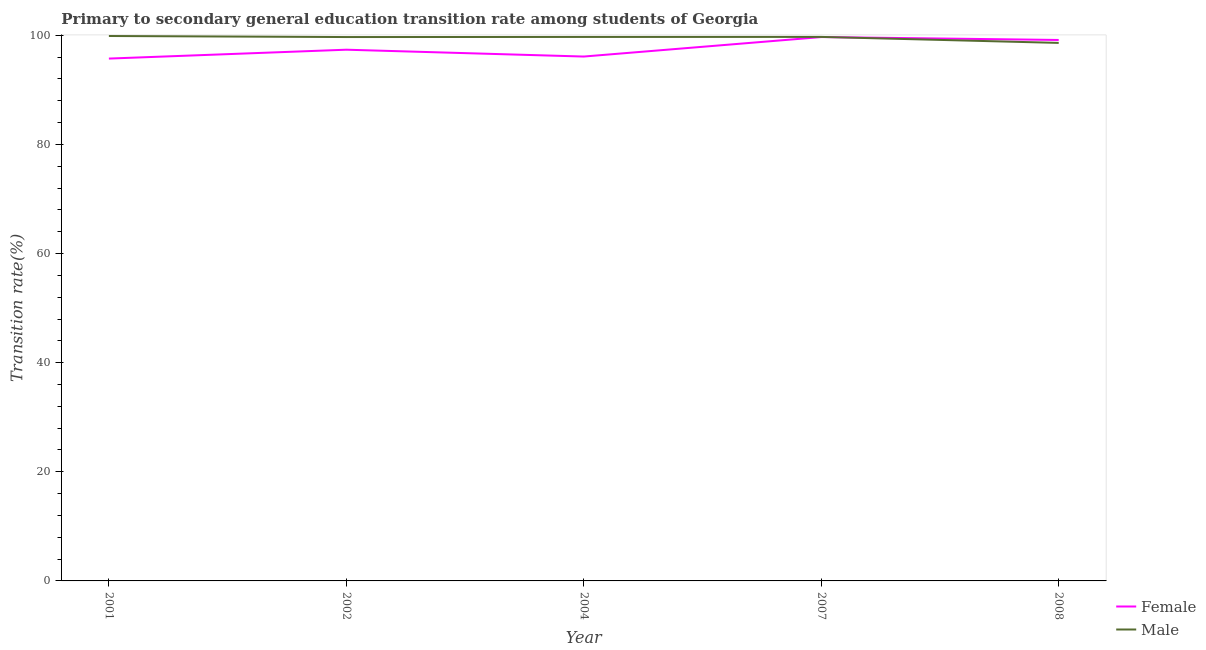What is the transition rate among male students in 2007?
Offer a terse response. 99.71. Across all years, what is the maximum transition rate among male students?
Offer a terse response. 99.88. Across all years, what is the minimum transition rate among male students?
Your response must be concise. 98.61. In which year was the transition rate among female students minimum?
Provide a succinct answer. 2001. What is the total transition rate among female students in the graph?
Your answer should be compact. 488.04. What is the difference between the transition rate among male students in 2002 and that in 2007?
Offer a terse response. -0.02. What is the difference between the transition rate among female students in 2002 and the transition rate among male students in 2008?
Provide a succinct answer. -1.24. What is the average transition rate among female students per year?
Your response must be concise. 97.61. In the year 2004, what is the difference between the transition rate among female students and transition rate among male students?
Provide a succinct answer. -3.59. What is the ratio of the transition rate among female students in 2002 to that in 2004?
Ensure brevity in your answer.  1.01. What is the difference between the highest and the second highest transition rate among male students?
Keep it short and to the point. 0.17. What is the difference between the highest and the lowest transition rate among male students?
Offer a very short reply. 1.27. Does the transition rate among female students monotonically increase over the years?
Your answer should be very brief. No. Is the transition rate among female students strictly less than the transition rate among male students over the years?
Keep it short and to the point. No. What is the difference between two consecutive major ticks on the Y-axis?
Your answer should be compact. 20. Are the values on the major ticks of Y-axis written in scientific E-notation?
Provide a succinct answer. No. Where does the legend appear in the graph?
Ensure brevity in your answer.  Bottom right. How many legend labels are there?
Provide a short and direct response. 2. How are the legend labels stacked?
Keep it short and to the point. Vertical. What is the title of the graph?
Your answer should be very brief. Primary to secondary general education transition rate among students of Georgia. Does "Manufacturing industries and construction" appear as one of the legend labels in the graph?
Ensure brevity in your answer.  No. What is the label or title of the X-axis?
Provide a succinct answer. Year. What is the label or title of the Y-axis?
Ensure brevity in your answer.  Transition rate(%). What is the Transition rate(%) of Female in 2001?
Keep it short and to the point. 95.74. What is the Transition rate(%) in Male in 2001?
Provide a succinct answer. 99.88. What is the Transition rate(%) of Female in 2002?
Give a very brief answer. 97.36. What is the Transition rate(%) of Male in 2002?
Offer a very short reply. 99.68. What is the Transition rate(%) of Female in 2004?
Offer a very short reply. 96.11. What is the Transition rate(%) in Male in 2004?
Offer a terse response. 99.7. What is the Transition rate(%) in Female in 2007?
Make the answer very short. 99.68. What is the Transition rate(%) of Male in 2007?
Provide a short and direct response. 99.71. What is the Transition rate(%) of Female in 2008?
Offer a very short reply. 99.15. What is the Transition rate(%) of Male in 2008?
Provide a succinct answer. 98.61. Across all years, what is the maximum Transition rate(%) of Female?
Keep it short and to the point. 99.68. Across all years, what is the maximum Transition rate(%) of Male?
Your response must be concise. 99.88. Across all years, what is the minimum Transition rate(%) in Female?
Offer a terse response. 95.74. Across all years, what is the minimum Transition rate(%) of Male?
Give a very brief answer. 98.61. What is the total Transition rate(%) of Female in the graph?
Your response must be concise. 488.04. What is the total Transition rate(%) in Male in the graph?
Give a very brief answer. 497.58. What is the difference between the Transition rate(%) in Female in 2001 and that in 2002?
Provide a short and direct response. -1.63. What is the difference between the Transition rate(%) of Male in 2001 and that in 2002?
Your answer should be very brief. 0.19. What is the difference between the Transition rate(%) of Female in 2001 and that in 2004?
Your answer should be very brief. -0.37. What is the difference between the Transition rate(%) of Male in 2001 and that in 2004?
Give a very brief answer. 0.17. What is the difference between the Transition rate(%) in Female in 2001 and that in 2007?
Provide a short and direct response. -3.95. What is the difference between the Transition rate(%) in Male in 2001 and that in 2007?
Make the answer very short. 0.17. What is the difference between the Transition rate(%) of Female in 2001 and that in 2008?
Give a very brief answer. -3.41. What is the difference between the Transition rate(%) in Male in 2001 and that in 2008?
Offer a terse response. 1.27. What is the difference between the Transition rate(%) in Female in 2002 and that in 2004?
Your answer should be very brief. 1.25. What is the difference between the Transition rate(%) of Male in 2002 and that in 2004?
Your answer should be compact. -0.02. What is the difference between the Transition rate(%) in Female in 2002 and that in 2007?
Your response must be concise. -2.32. What is the difference between the Transition rate(%) of Male in 2002 and that in 2007?
Your answer should be very brief. -0.02. What is the difference between the Transition rate(%) of Female in 2002 and that in 2008?
Offer a very short reply. -1.78. What is the difference between the Transition rate(%) of Male in 2002 and that in 2008?
Offer a terse response. 1.08. What is the difference between the Transition rate(%) of Female in 2004 and that in 2007?
Offer a terse response. -3.57. What is the difference between the Transition rate(%) of Male in 2004 and that in 2007?
Ensure brevity in your answer.  -0. What is the difference between the Transition rate(%) of Female in 2004 and that in 2008?
Your response must be concise. -3.04. What is the difference between the Transition rate(%) in Male in 2004 and that in 2008?
Your answer should be very brief. 1.1. What is the difference between the Transition rate(%) in Female in 2007 and that in 2008?
Your answer should be compact. 0.54. What is the difference between the Transition rate(%) in Male in 2007 and that in 2008?
Provide a succinct answer. 1.1. What is the difference between the Transition rate(%) in Female in 2001 and the Transition rate(%) in Male in 2002?
Ensure brevity in your answer.  -3.95. What is the difference between the Transition rate(%) in Female in 2001 and the Transition rate(%) in Male in 2004?
Ensure brevity in your answer.  -3.97. What is the difference between the Transition rate(%) of Female in 2001 and the Transition rate(%) of Male in 2007?
Offer a very short reply. -3.97. What is the difference between the Transition rate(%) of Female in 2001 and the Transition rate(%) of Male in 2008?
Offer a very short reply. -2.87. What is the difference between the Transition rate(%) of Female in 2002 and the Transition rate(%) of Male in 2004?
Your answer should be compact. -2.34. What is the difference between the Transition rate(%) in Female in 2002 and the Transition rate(%) in Male in 2007?
Offer a very short reply. -2.34. What is the difference between the Transition rate(%) of Female in 2002 and the Transition rate(%) of Male in 2008?
Make the answer very short. -1.24. What is the difference between the Transition rate(%) in Female in 2004 and the Transition rate(%) in Male in 2007?
Your answer should be compact. -3.6. What is the difference between the Transition rate(%) in Female in 2004 and the Transition rate(%) in Male in 2008?
Give a very brief answer. -2.5. What is the difference between the Transition rate(%) of Female in 2007 and the Transition rate(%) of Male in 2008?
Your answer should be very brief. 1.07. What is the average Transition rate(%) in Female per year?
Keep it short and to the point. 97.61. What is the average Transition rate(%) of Male per year?
Your response must be concise. 99.52. In the year 2001, what is the difference between the Transition rate(%) in Female and Transition rate(%) in Male?
Your response must be concise. -4.14. In the year 2002, what is the difference between the Transition rate(%) of Female and Transition rate(%) of Male?
Offer a very short reply. -2.32. In the year 2004, what is the difference between the Transition rate(%) of Female and Transition rate(%) of Male?
Offer a terse response. -3.59. In the year 2007, what is the difference between the Transition rate(%) in Female and Transition rate(%) in Male?
Make the answer very short. -0.03. In the year 2008, what is the difference between the Transition rate(%) in Female and Transition rate(%) in Male?
Provide a short and direct response. 0.54. What is the ratio of the Transition rate(%) of Female in 2001 to that in 2002?
Provide a short and direct response. 0.98. What is the ratio of the Transition rate(%) of Male in 2001 to that in 2002?
Offer a very short reply. 1. What is the ratio of the Transition rate(%) of Female in 2001 to that in 2004?
Ensure brevity in your answer.  1. What is the ratio of the Transition rate(%) in Male in 2001 to that in 2004?
Ensure brevity in your answer.  1. What is the ratio of the Transition rate(%) of Female in 2001 to that in 2007?
Provide a succinct answer. 0.96. What is the ratio of the Transition rate(%) of Male in 2001 to that in 2007?
Provide a short and direct response. 1. What is the ratio of the Transition rate(%) of Female in 2001 to that in 2008?
Provide a succinct answer. 0.97. What is the ratio of the Transition rate(%) of Male in 2001 to that in 2008?
Your answer should be very brief. 1.01. What is the ratio of the Transition rate(%) in Female in 2002 to that in 2007?
Provide a succinct answer. 0.98. What is the ratio of the Transition rate(%) in Male in 2002 to that in 2007?
Ensure brevity in your answer.  1. What is the ratio of the Transition rate(%) in Female in 2002 to that in 2008?
Offer a terse response. 0.98. What is the ratio of the Transition rate(%) in Male in 2002 to that in 2008?
Provide a short and direct response. 1.01. What is the ratio of the Transition rate(%) in Female in 2004 to that in 2007?
Offer a very short reply. 0.96. What is the ratio of the Transition rate(%) in Female in 2004 to that in 2008?
Offer a terse response. 0.97. What is the ratio of the Transition rate(%) of Male in 2004 to that in 2008?
Offer a terse response. 1.01. What is the ratio of the Transition rate(%) in Female in 2007 to that in 2008?
Keep it short and to the point. 1.01. What is the ratio of the Transition rate(%) of Male in 2007 to that in 2008?
Your answer should be very brief. 1.01. What is the difference between the highest and the second highest Transition rate(%) in Female?
Provide a succinct answer. 0.54. What is the difference between the highest and the second highest Transition rate(%) in Male?
Your answer should be compact. 0.17. What is the difference between the highest and the lowest Transition rate(%) in Female?
Keep it short and to the point. 3.95. What is the difference between the highest and the lowest Transition rate(%) in Male?
Ensure brevity in your answer.  1.27. 